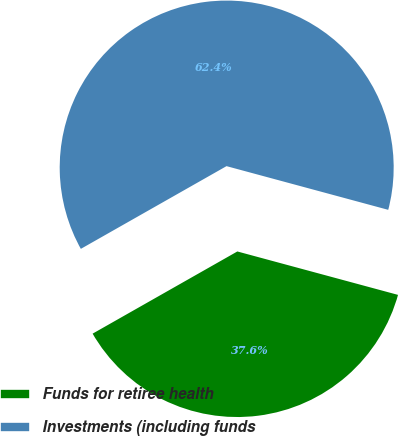Convert chart to OTSL. <chart><loc_0><loc_0><loc_500><loc_500><pie_chart><fcel>Funds for retiree health<fcel>Investments (including funds<nl><fcel>37.58%<fcel>62.42%<nl></chart> 